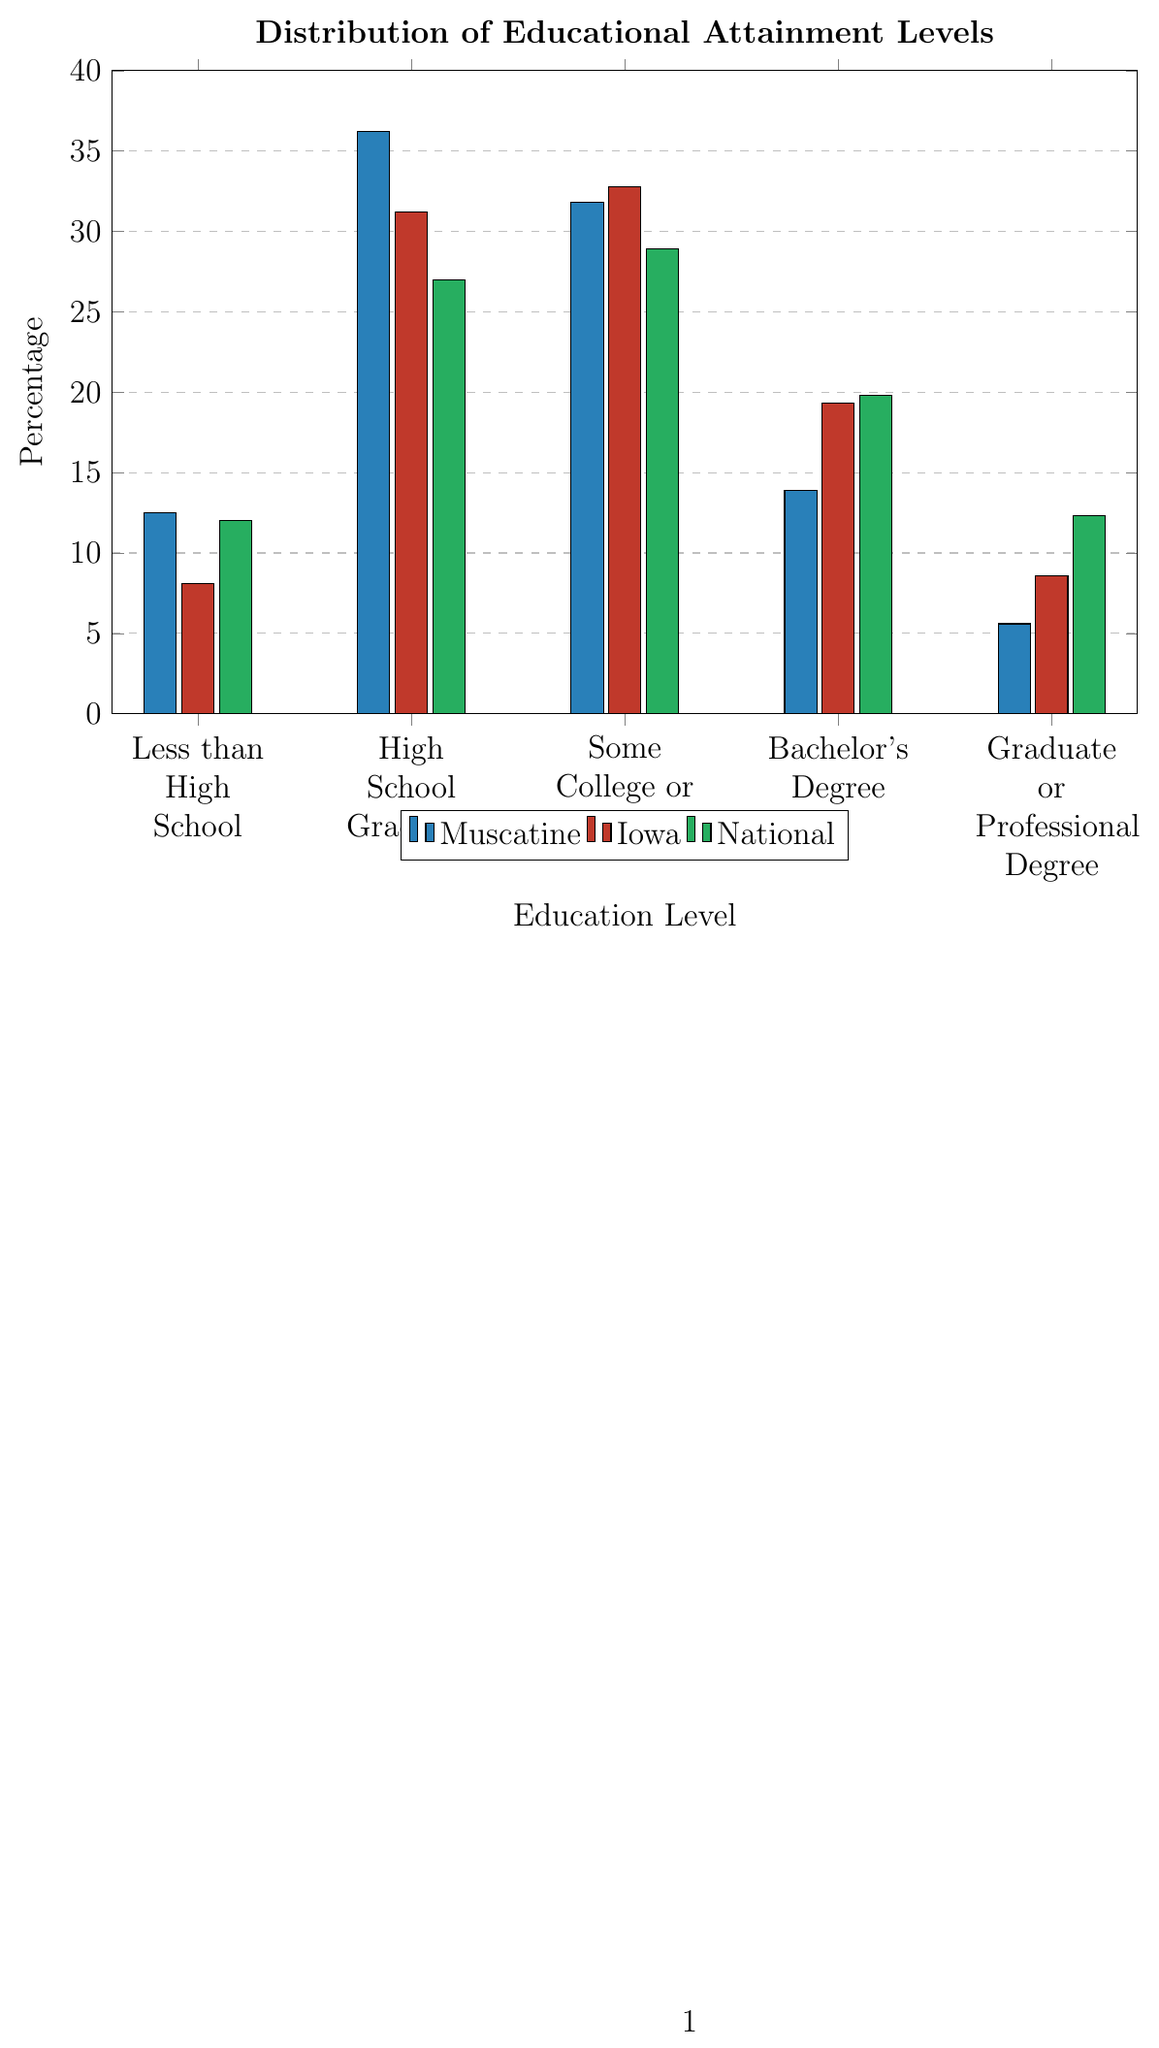Which region has the highest percentage of high school graduates? The figure shows bar heights of different educational attainment levels for Muscatine, Iowa, and National. The bar for "High School Graduate" reaches the highest percentage in Muscatine compared to the other regions.
Answer: Muscatine What is the difference in percentage between Muscatine and the National average for those with a Bachelor's Degree? To find the difference, subtract the percentage for Muscatine from the National percentage: 19.8 - 13.9 = 5.9
Answer: 5.9 Among Muscatine, Iowa, and the National average, which has the lowest percentage of people with less than a high school education? The figure shows the bar heights for "Less than High School". Iowa has the lowest bar height for this category, indicating the lowest percentage.
Answer: Iowa Compare the percentage of people with Graduate or Professional Degrees in Muscatine to Iowa. What is the percentage difference? Subtract the percentage for Muscatine from Iowa for "Graduate or Professional Degree": 8.6 - 5.6 = 3.0
Answer: 3.0 What is the combined percentage of high school graduates and people with some college or associate's degree in Muscatine? Add the percentages for "High School Graduate" and "Some College or Associate's": 36.2 + 31.8 = 68.0
Answer: 68.0 Which category shows the greatest disparity between Muscatine and the National average? Examine each category and calculate the differences between Muscatine and the National average. For "Graduate or Professional Degree", the difference is the largest: 12.3 - 5.6 = 6.7
Answer: Graduate or Professional Degree In which educational level does Iowa exceed Muscatine the most in percentage points? Compare the percentages for each educational level, and find the largest difference. For "Bachelor's Degree", Iowa exceeds Muscatine by the greatest amount: 19.3 - 13.9 = 5.4
Answer: Bachelor's Degree 